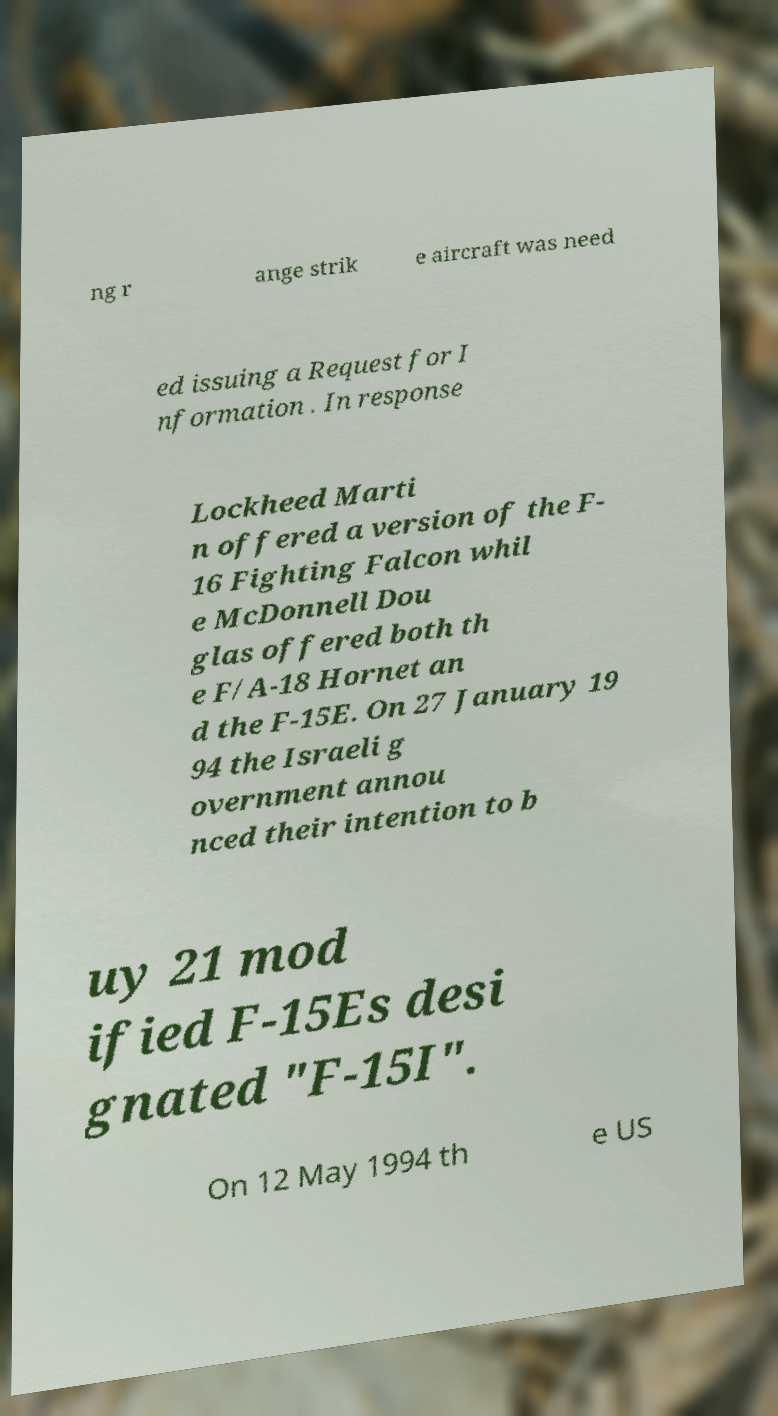Please identify and transcribe the text found in this image. ng r ange strik e aircraft was need ed issuing a Request for I nformation . In response Lockheed Marti n offered a version of the F- 16 Fighting Falcon whil e McDonnell Dou glas offered both th e F/A-18 Hornet an d the F-15E. On 27 January 19 94 the Israeli g overnment annou nced their intention to b uy 21 mod ified F-15Es desi gnated "F-15I". On 12 May 1994 th e US 